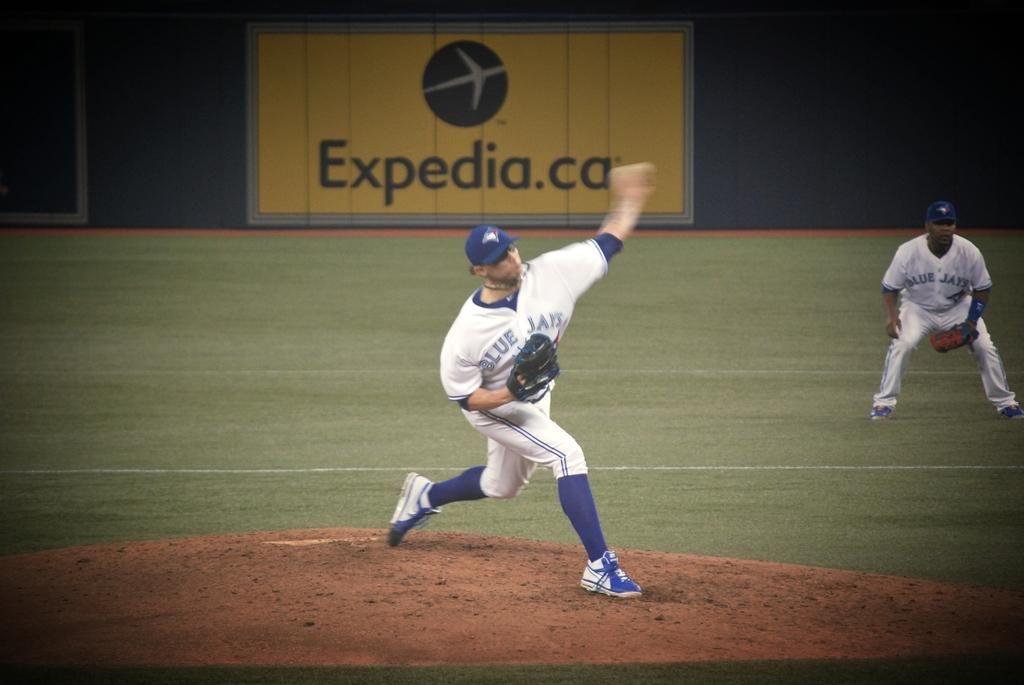<image>
Give a short and clear explanation of the subsequent image. A pitcher winds up to throw the ball in front of an Expedia.ca billboard. 